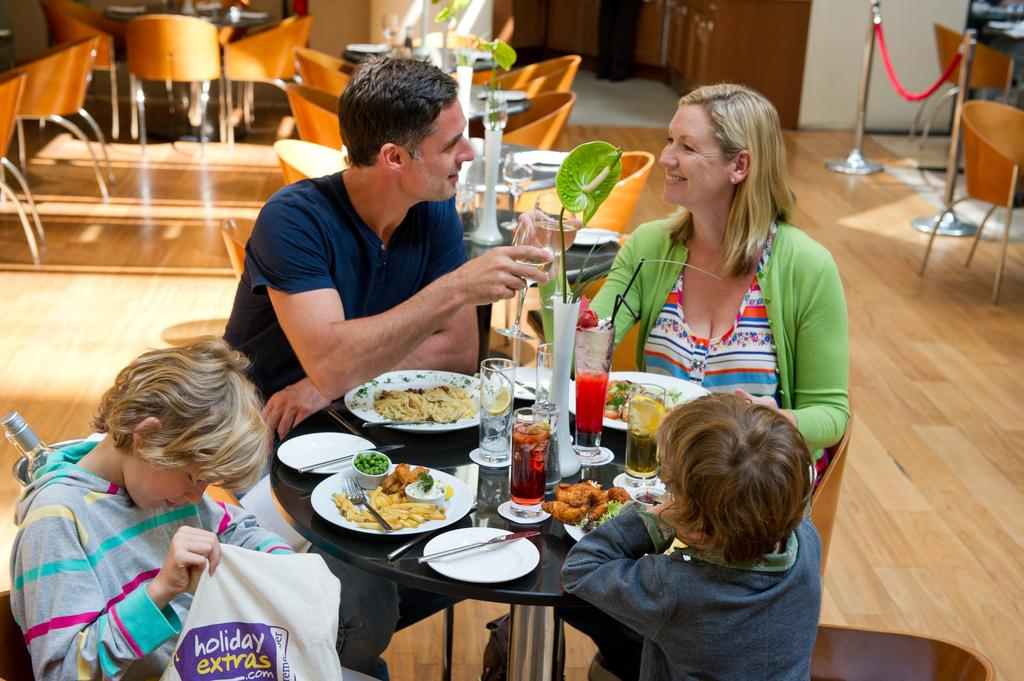How many people are in the image? There is a group of people in the image. What are the people doing in the image? The people are sitting around a table. What can be seen on the table in the image? There are plates with food, glasses, spoons, knives, and a plant on the table. What type of thread is being used to sew the plant in the image? There is no thread or sewing activity present in the image; the plant is simply placed on the table. 